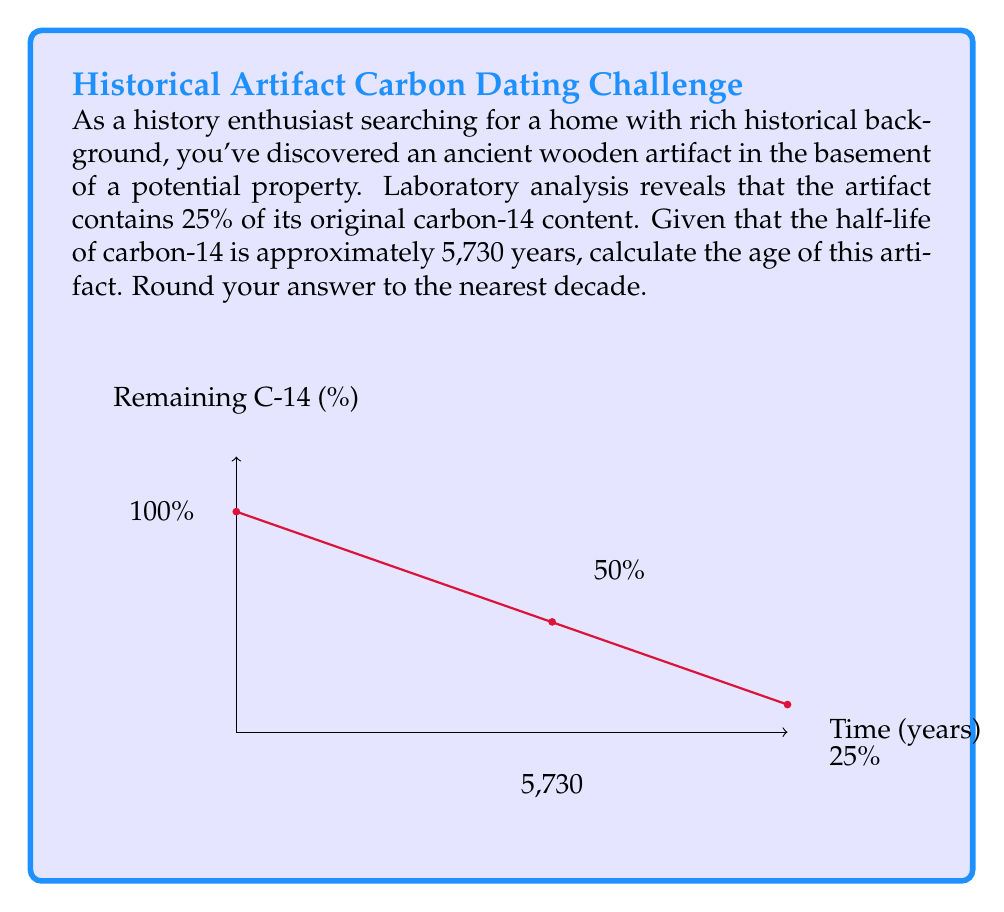Solve this math problem. To solve this problem, we'll use the radioactive decay formula and the given information:

1) The general formula for radioactive decay is:
   $$N(t) = N_0 \cdot (0.5)^{t/t_{1/2}}$$
   Where:
   $N(t)$ is the amount remaining after time $t$
   $N_0$ is the initial amount
   $t$ is the time elapsed
   $t_{1/2}$ is the half-life

2) We know that 25% of the original carbon-14 remains, so:
   $$0.25 = (0.5)^{t/5730}$$

3) Taking the natural log of both sides:
   $$\ln(0.25) = \ln((0.5)^{t/5730})$$

4) Using the logarithm property $\ln(a^b) = b\ln(a)$:
   $$\ln(0.25) = \frac{t}{5730} \cdot \ln(0.5)$$

5) Solving for $t$:
   $$t = 5730 \cdot \frac{\ln(0.25)}{\ln(0.5)}$$

6) Calculating:
   $$t \approx 11,460 \text{ years}$$

7) Rounding to the nearest decade:
   $$t \approx 11,460 \text{ years}$$
Answer: 11,460 years 